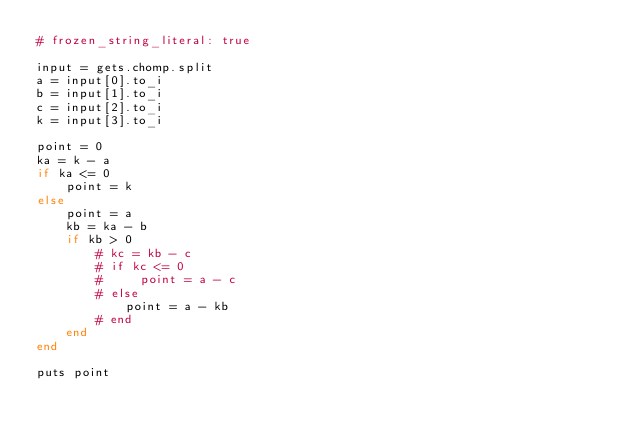Convert code to text. <code><loc_0><loc_0><loc_500><loc_500><_Ruby_># frozen_string_literal: true

input = gets.chomp.split
a = input[0].to_i
b = input[1].to_i
c = input[2].to_i
k = input[3].to_i

point = 0
ka = k - a
if ka <= 0
    point = k
else
    point = a
    kb = ka - b
    if kb > 0
        # kc = kb - c
        # if kc <= 0
        #     point = a - c
        # else
            point = a - kb
        # end
    end
end

puts point
</code> 